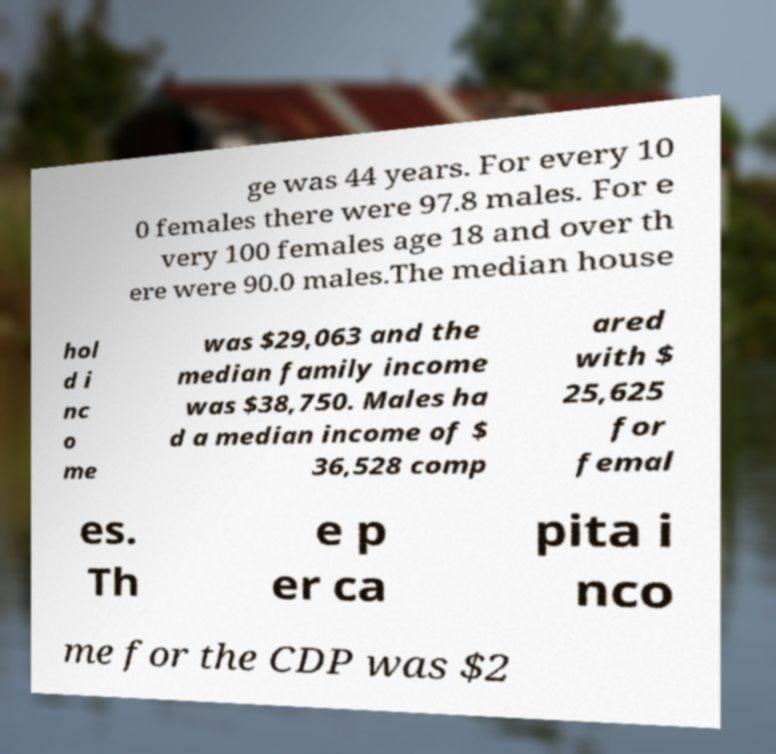Could you extract and type out the text from this image? ge was 44 years. For every 10 0 females there were 97.8 males. For e very 100 females age 18 and over th ere were 90.0 males.The median house hol d i nc o me was $29,063 and the median family income was $38,750. Males ha d a median income of $ 36,528 comp ared with $ 25,625 for femal es. Th e p er ca pita i nco me for the CDP was $2 